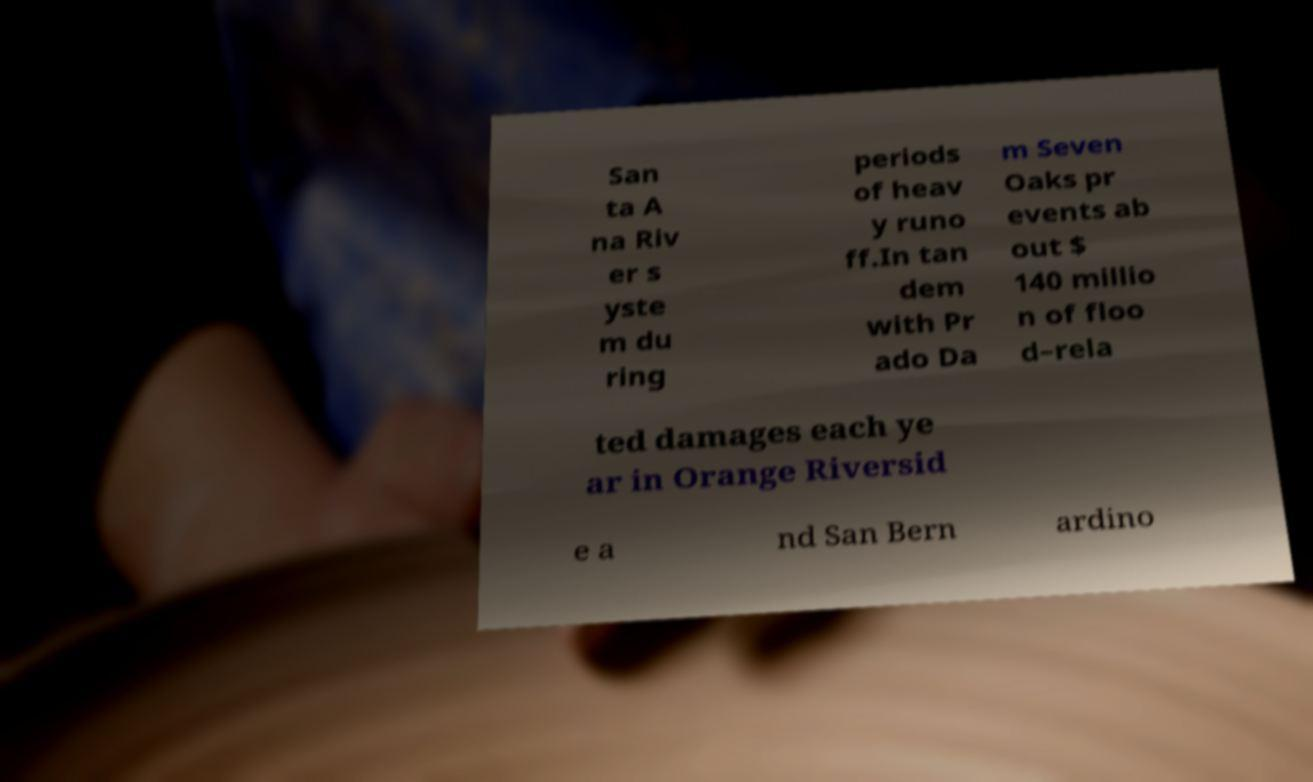Please identify and transcribe the text found in this image. San ta A na Riv er s yste m du ring periods of heav y runo ff.In tan dem with Pr ado Da m Seven Oaks pr events ab out $ 140 millio n of floo d–rela ted damages each ye ar in Orange Riversid e a nd San Bern ardino 